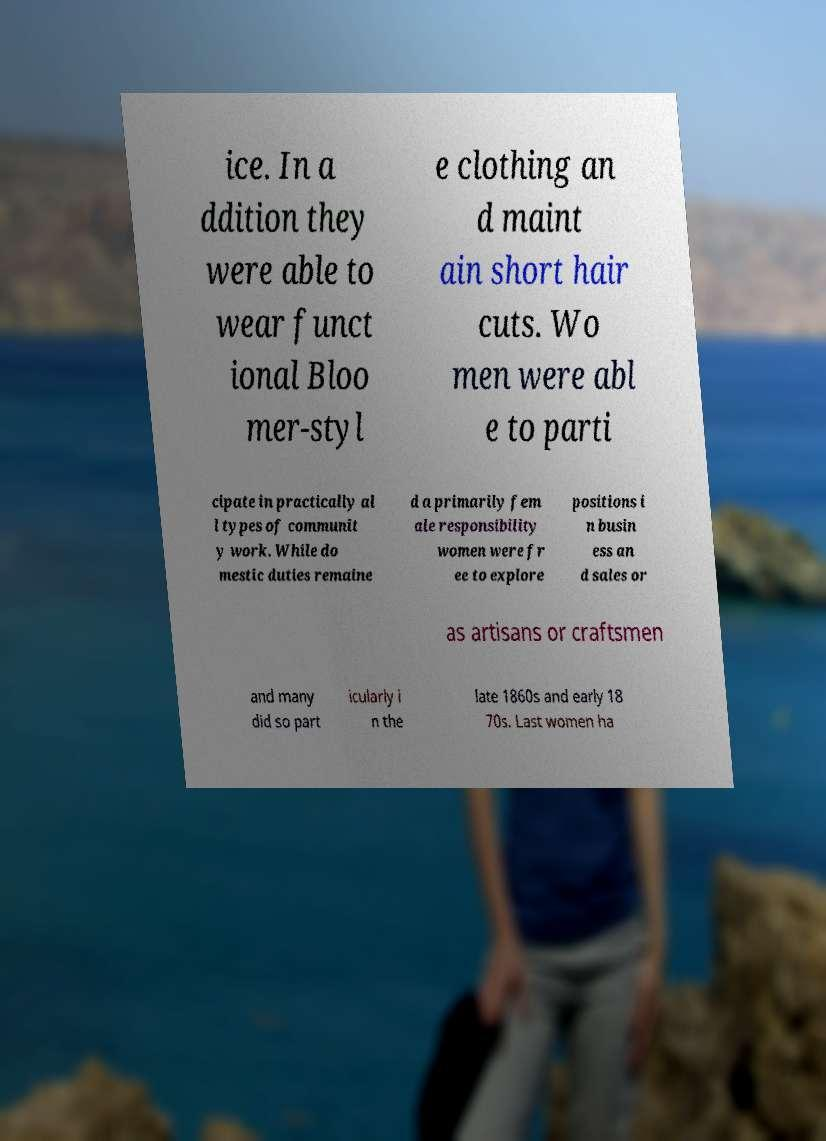What messages or text are displayed in this image? I need them in a readable, typed format. ice. In a ddition they were able to wear funct ional Bloo mer-styl e clothing an d maint ain short hair cuts. Wo men were abl e to parti cipate in practically al l types of communit y work. While do mestic duties remaine d a primarily fem ale responsibility women were fr ee to explore positions i n busin ess an d sales or as artisans or craftsmen and many did so part icularly i n the late 1860s and early 18 70s. Last women ha 